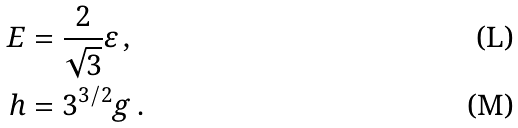<formula> <loc_0><loc_0><loc_500><loc_500>E & = \frac { 2 } { \sqrt { 3 } } \varepsilon \, , \\ h & = 3 ^ { 3 / 2 } g \, .</formula> 